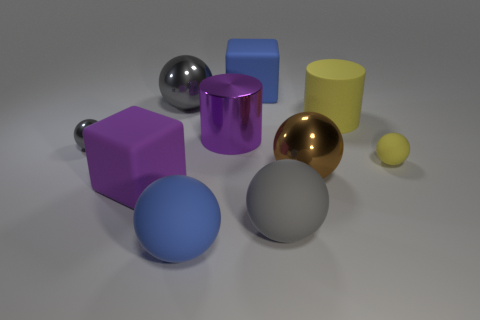There is a matte object that is in front of the blue block and behind the tiny shiny thing; how big is it?
Provide a short and direct response. Large. What shape is the object that is both left of the large gray shiny object and to the right of the small metallic thing?
Your response must be concise. Cube. Are any big brown metallic blocks visible?
Your answer should be compact. No. What material is the purple thing that is the same shape as the large yellow object?
Provide a succinct answer. Metal. What shape is the big yellow matte thing right of the big matte object behind the large cylinder that is to the right of the large blue block?
Provide a short and direct response. Cylinder. There is a large cylinder that is the same color as the tiny rubber object; what is its material?
Make the answer very short. Rubber. What number of big gray metal objects have the same shape as the tiny yellow rubber thing?
Provide a succinct answer. 1. Does the matte cube on the left side of the large blue rubber cube have the same color as the matte sphere that is on the left side of the gray matte sphere?
Offer a very short reply. No. There is a purple block that is the same size as the metallic cylinder; what is it made of?
Your response must be concise. Rubber. Is there a brown metallic thing that has the same size as the metal cylinder?
Provide a succinct answer. Yes. 